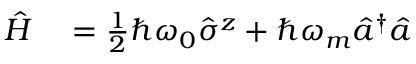<formula> <loc_0><loc_0><loc_500><loc_500>\begin{array} { r l } { \hat { H } } & = \frac { 1 } { 2 } \hbar { \omega } _ { 0 } \hat { \sigma } ^ { z } + \hbar { \omega } _ { m } \hat { a } ^ { \dagger } \hat { a } } \end{array}</formula> 